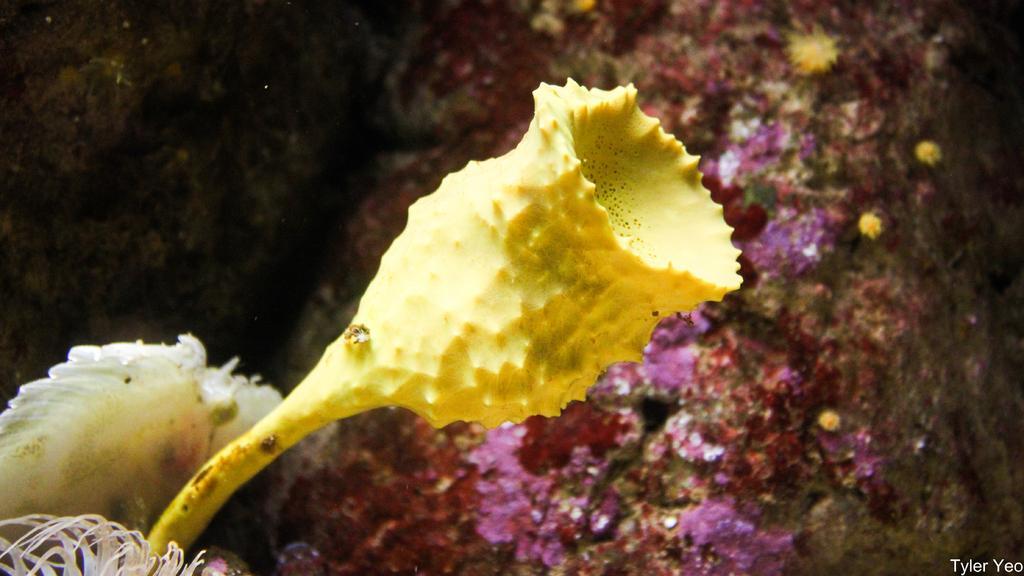Describe this image in one or two sentences. In this picture we can see flowers and in the background we can see rocks. 